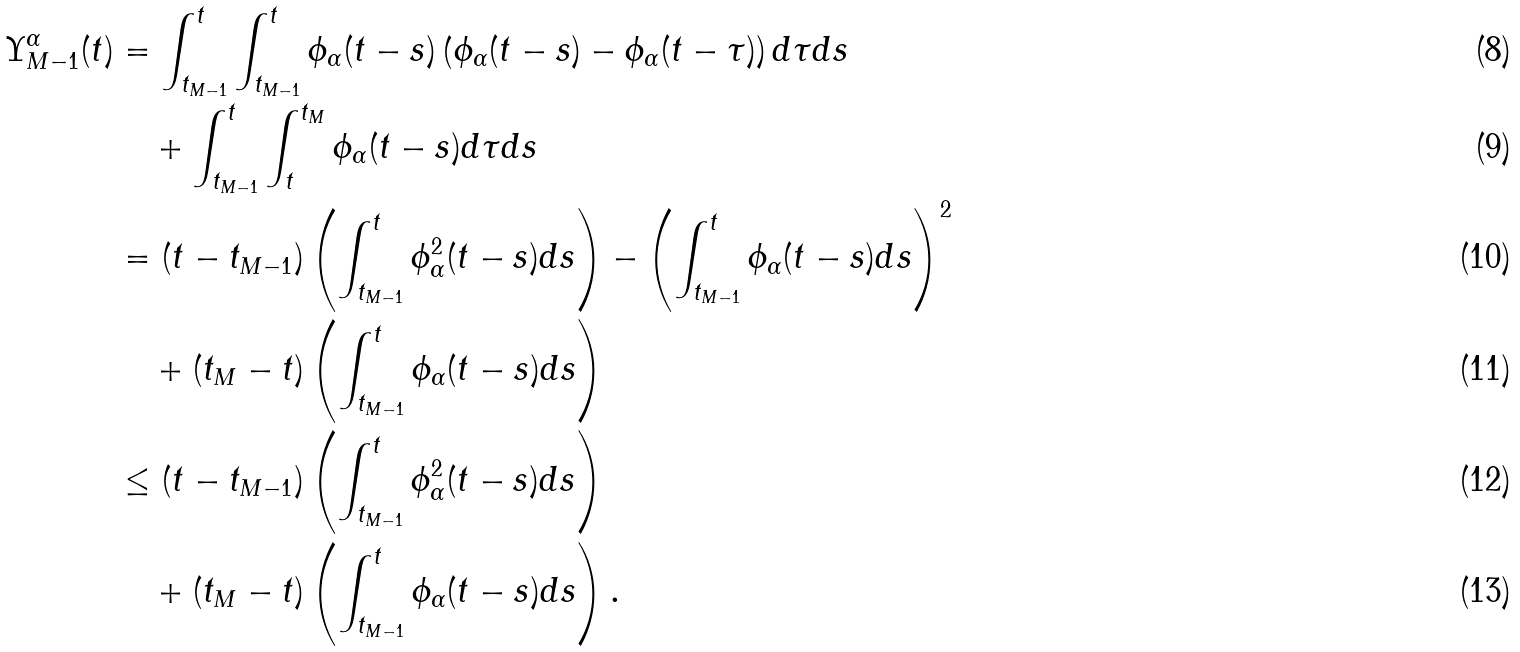<formula> <loc_0><loc_0><loc_500><loc_500>\Upsilon _ { M - 1 } ^ { \alpha } ( t ) & = \int _ { t _ { M - 1 } } ^ { t } \int _ { t _ { M - 1 } } ^ { t } \phi _ { \alpha } ( t - s ) \left ( \phi _ { \alpha } ( t - s ) - \phi _ { \alpha } ( t - \tau ) \right ) d \tau d s \\ & \quad + \int _ { t _ { M - 1 } } ^ { t } \int _ { t } ^ { t _ { M } } \phi _ { \alpha } ( t - s ) d \tau d s \\ & = ( t - t _ { M - 1 } ) \left ( \int _ { t _ { M - 1 } } ^ { t } \phi ^ { 2 } _ { \alpha } ( t - s ) d s \right ) - \left ( \int _ { t _ { M - 1 } } ^ { t } \phi _ { \alpha } ( t - s ) d s \right ) ^ { 2 } \\ & \quad + ( t _ { M } - t ) \left ( \int _ { t _ { M - 1 } } ^ { t } \phi _ { \alpha } ( t - s ) d s \right ) \\ & \leq ( t - t _ { M - 1 } ) \left ( \int _ { t _ { M - 1 } } ^ { t } \phi ^ { 2 } _ { \alpha } ( t - s ) d s \right ) \\ & \quad + ( t _ { M } - t ) \left ( \int _ { t _ { M - 1 } } ^ { t } \phi _ { \alpha } ( t - s ) d s \right ) .</formula> 